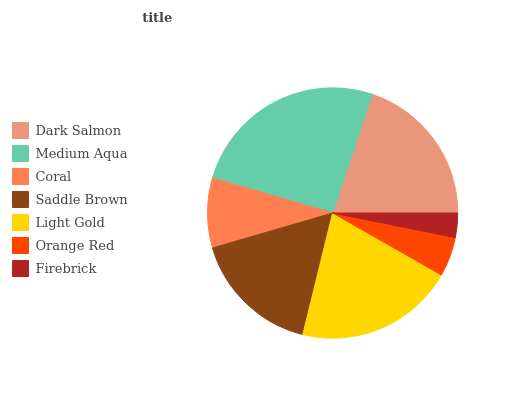Is Firebrick the minimum?
Answer yes or no. Yes. Is Medium Aqua the maximum?
Answer yes or no. Yes. Is Coral the minimum?
Answer yes or no. No. Is Coral the maximum?
Answer yes or no. No. Is Medium Aqua greater than Coral?
Answer yes or no. Yes. Is Coral less than Medium Aqua?
Answer yes or no. Yes. Is Coral greater than Medium Aqua?
Answer yes or no. No. Is Medium Aqua less than Coral?
Answer yes or no. No. Is Saddle Brown the high median?
Answer yes or no. Yes. Is Saddle Brown the low median?
Answer yes or no. Yes. Is Light Gold the high median?
Answer yes or no. No. Is Light Gold the low median?
Answer yes or no. No. 